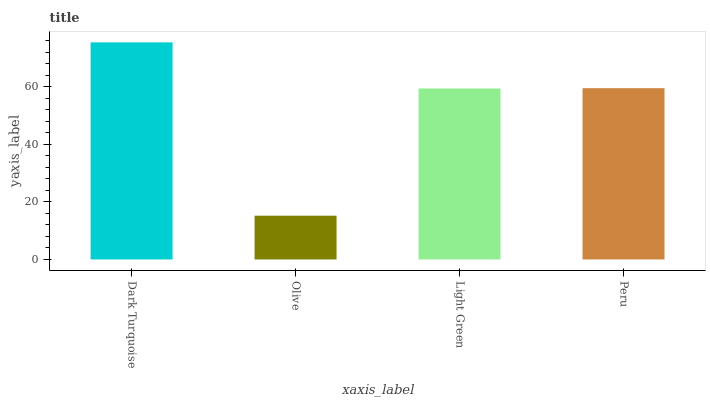Is Olive the minimum?
Answer yes or no. Yes. Is Dark Turquoise the maximum?
Answer yes or no. Yes. Is Light Green the minimum?
Answer yes or no. No. Is Light Green the maximum?
Answer yes or no. No. Is Light Green greater than Olive?
Answer yes or no. Yes. Is Olive less than Light Green?
Answer yes or no. Yes. Is Olive greater than Light Green?
Answer yes or no. No. Is Light Green less than Olive?
Answer yes or no. No. Is Peru the high median?
Answer yes or no. Yes. Is Light Green the low median?
Answer yes or no. Yes. Is Olive the high median?
Answer yes or no. No. Is Dark Turquoise the low median?
Answer yes or no. No. 